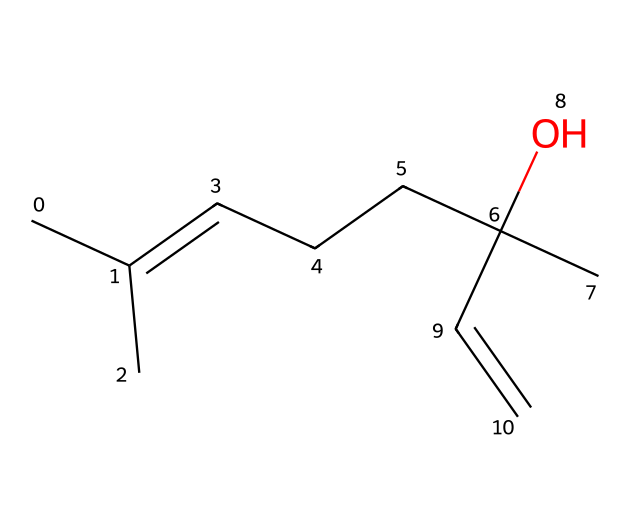How many carbon atoms are in linalool? By examining the structure represented by the SMILES, we can count the number of carbon (C) atoms present. For this SMILES, there are 10 carbon atoms indicated.
Answer: 10 How many hydrogen atoms are attached to linalool? Each carbon atom typically forms four bonds. In the structure provided, after considering the bond arrangements and the presence of functional groups, the total number of hydrogen atoms can be counted to be 18.
Answer: 18 What functional group is present in linalool? By analyzing the SMILES representation, the presence of the -OH (hydroxyl) group signifies that linalool has a functional group characteristic of alcohols.
Answer: hydroxyl Is linalool saturated or unsaturated? The SMILES indicates there are double bonds present in the structure (specifically the C=C bond), which indicates that linalool is an unsaturated compound.
Answer: unsaturated What is the total number of double bonds in linalool? The structure shows one double bond within the molecule. Upon examining the representation closely, we find only one occurrence of a double bond.
Answer: 1 What type of natural compounds does linalool belong to? Linalool is recognized as a type of terpene, which are natural compounds known for their aromatic properties, particularly in essential oils.
Answer: terpenes What aromatic characteristic is associated with linalool? The chemical structure of linalool suggests a floral aroma due to the specific arrangement of its atoms and the presence of the hydroxyl group, which enhances its scent profile.
Answer: floral aroma 